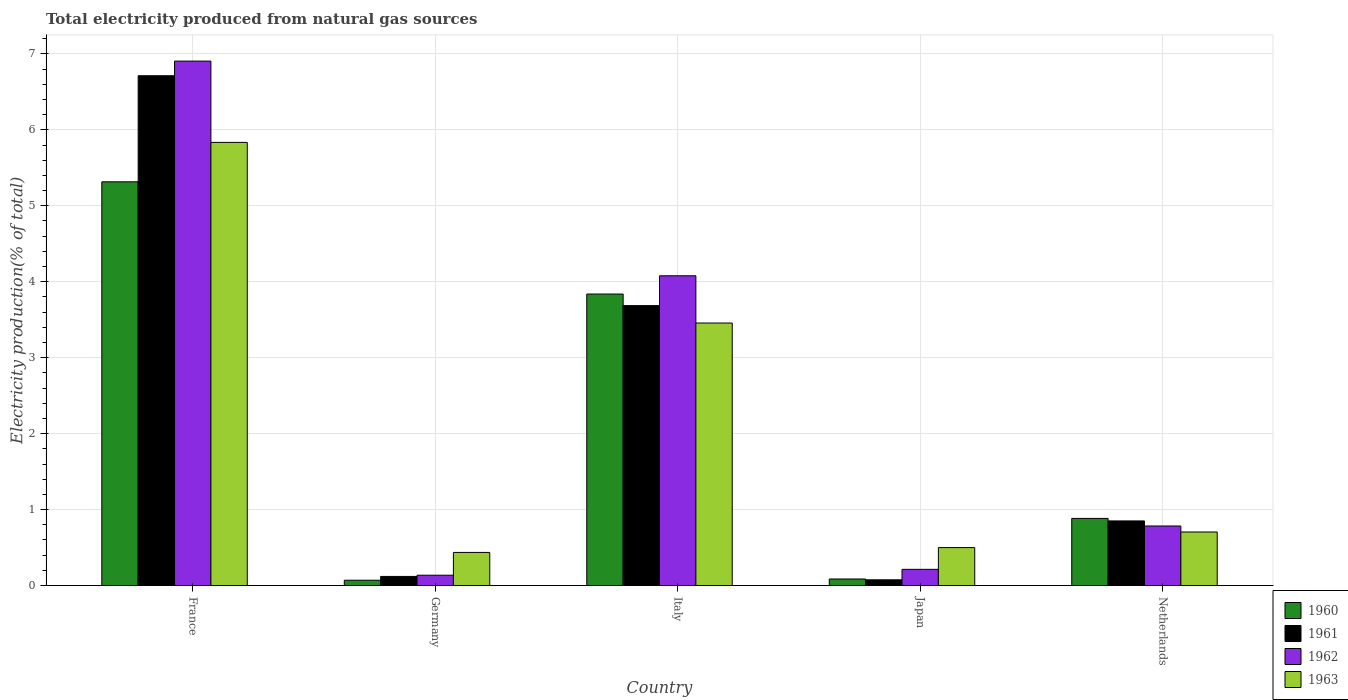How many different coloured bars are there?
Make the answer very short. 4. Are the number of bars per tick equal to the number of legend labels?
Give a very brief answer. Yes. How many bars are there on the 2nd tick from the left?
Offer a terse response. 4. How many bars are there on the 5th tick from the right?
Give a very brief answer. 4. What is the label of the 5th group of bars from the left?
Make the answer very short. Netherlands. What is the total electricity produced in 1961 in Japan?
Your response must be concise. 0.08. Across all countries, what is the maximum total electricity produced in 1961?
Give a very brief answer. 6.71. Across all countries, what is the minimum total electricity produced in 1962?
Your answer should be compact. 0.14. In which country was the total electricity produced in 1961 maximum?
Ensure brevity in your answer.  France. In which country was the total electricity produced in 1963 minimum?
Your response must be concise. Germany. What is the total total electricity produced in 1960 in the graph?
Offer a very short reply. 10.19. What is the difference between the total electricity produced in 1963 in France and that in Japan?
Provide a short and direct response. 5.33. What is the difference between the total electricity produced in 1960 in Japan and the total electricity produced in 1961 in Italy?
Ensure brevity in your answer.  -3.6. What is the average total electricity produced in 1962 per country?
Offer a terse response. 2.42. What is the difference between the total electricity produced of/in 1963 and total electricity produced of/in 1961 in Netherlands?
Provide a short and direct response. -0.15. In how many countries, is the total electricity produced in 1962 greater than 2.8 %?
Offer a terse response. 2. What is the ratio of the total electricity produced in 1960 in Germany to that in Italy?
Your response must be concise. 0.02. Is the difference between the total electricity produced in 1963 in Italy and Japan greater than the difference between the total electricity produced in 1961 in Italy and Japan?
Your response must be concise. No. What is the difference between the highest and the second highest total electricity produced in 1962?
Provide a succinct answer. -3.29. What is the difference between the highest and the lowest total electricity produced in 1960?
Your answer should be very brief. 5.25. In how many countries, is the total electricity produced in 1960 greater than the average total electricity produced in 1960 taken over all countries?
Provide a short and direct response. 2. What does the 3rd bar from the right in Germany represents?
Keep it short and to the point. 1961. How many bars are there?
Offer a very short reply. 20. Are all the bars in the graph horizontal?
Provide a short and direct response. No. How many countries are there in the graph?
Keep it short and to the point. 5. What is the difference between two consecutive major ticks on the Y-axis?
Keep it short and to the point. 1. Does the graph contain any zero values?
Your response must be concise. No. Does the graph contain grids?
Provide a succinct answer. Yes. Where does the legend appear in the graph?
Your answer should be compact. Bottom right. How are the legend labels stacked?
Ensure brevity in your answer.  Vertical. What is the title of the graph?
Ensure brevity in your answer.  Total electricity produced from natural gas sources. Does "1964" appear as one of the legend labels in the graph?
Offer a terse response. No. What is the label or title of the Y-axis?
Offer a terse response. Electricity production(% of total). What is the Electricity production(% of total) in 1960 in France?
Provide a short and direct response. 5.32. What is the Electricity production(% of total) of 1961 in France?
Make the answer very short. 6.71. What is the Electricity production(% of total) in 1962 in France?
Ensure brevity in your answer.  6.91. What is the Electricity production(% of total) of 1963 in France?
Provide a short and direct response. 5.83. What is the Electricity production(% of total) in 1960 in Germany?
Your response must be concise. 0.07. What is the Electricity production(% of total) in 1961 in Germany?
Your answer should be very brief. 0.12. What is the Electricity production(% of total) in 1962 in Germany?
Make the answer very short. 0.14. What is the Electricity production(% of total) in 1963 in Germany?
Offer a terse response. 0.44. What is the Electricity production(% of total) in 1960 in Italy?
Ensure brevity in your answer.  3.84. What is the Electricity production(% of total) in 1961 in Italy?
Your answer should be very brief. 3.69. What is the Electricity production(% of total) of 1962 in Italy?
Make the answer very short. 4.08. What is the Electricity production(% of total) of 1963 in Italy?
Ensure brevity in your answer.  3.46. What is the Electricity production(% of total) of 1960 in Japan?
Provide a short and direct response. 0.09. What is the Electricity production(% of total) in 1961 in Japan?
Provide a short and direct response. 0.08. What is the Electricity production(% of total) in 1962 in Japan?
Offer a very short reply. 0.21. What is the Electricity production(% of total) in 1963 in Japan?
Your response must be concise. 0.5. What is the Electricity production(% of total) of 1960 in Netherlands?
Provide a succinct answer. 0.88. What is the Electricity production(% of total) in 1961 in Netherlands?
Offer a very short reply. 0.85. What is the Electricity production(% of total) in 1962 in Netherlands?
Keep it short and to the point. 0.78. What is the Electricity production(% of total) in 1963 in Netherlands?
Offer a very short reply. 0.71. Across all countries, what is the maximum Electricity production(% of total) in 1960?
Make the answer very short. 5.32. Across all countries, what is the maximum Electricity production(% of total) in 1961?
Offer a very short reply. 6.71. Across all countries, what is the maximum Electricity production(% of total) in 1962?
Your response must be concise. 6.91. Across all countries, what is the maximum Electricity production(% of total) in 1963?
Make the answer very short. 5.83. Across all countries, what is the minimum Electricity production(% of total) in 1960?
Give a very brief answer. 0.07. Across all countries, what is the minimum Electricity production(% of total) of 1961?
Offer a very short reply. 0.08. Across all countries, what is the minimum Electricity production(% of total) of 1962?
Make the answer very short. 0.14. Across all countries, what is the minimum Electricity production(% of total) in 1963?
Keep it short and to the point. 0.44. What is the total Electricity production(% of total) of 1960 in the graph?
Offer a very short reply. 10.19. What is the total Electricity production(% of total) in 1961 in the graph?
Offer a terse response. 11.45. What is the total Electricity production(% of total) of 1962 in the graph?
Ensure brevity in your answer.  12.12. What is the total Electricity production(% of total) in 1963 in the graph?
Your response must be concise. 10.93. What is the difference between the Electricity production(% of total) in 1960 in France and that in Germany?
Keep it short and to the point. 5.25. What is the difference between the Electricity production(% of total) in 1961 in France and that in Germany?
Offer a terse response. 6.59. What is the difference between the Electricity production(% of total) in 1962 in France and that in Germany?
Offer a very short reply. 6.77. What is the difference between the Electricity production(% of total) of 1963 in France and that in Germany?
Your answer should be very brief. 5.4. What is the difference between the Electricity production(% of total) in 1960 in France and that in Italy?
Your answer should be very brief. 1.48. What is the difference between the Electricity production(% of total) of 1961 in France and that in Italy?
Make the answer very short. 3.03. What is the difference between the Electricity production(% of total) of 1962 in France and that in Italy?
Your answer should be compact. 2.83. What is the difference between the Electricity production(% of total) of 1963 in France and that in Italy?
Offer a very short reply. 2.38. What is the difference between the Electricity production(% of total) of 1960 in France and that in Japan?
Ensure brevity in your answer.  5.23. What is the difference between the Electricity production(% of total) of 1961 in France and that in Japan?
Your answer should be compact. 6.64. What is the difference between the Electricity production(% of total) in 1962 in France and that in Japan?
Provide a short and direct response. 6.69. What is the difference between the Electricity production(% of total) of 1963 in France and that in Japan?
Your answer should be compact. 5.33. What is the difference between the Electricity production(% of total) of 1960 in France and that in Netherlands?
Make the answer very short. 4.43. What is the difference between the Electricity production(% of total) in 1961 in France and that in Netherlands?
Give a very brief answer. 5.86. What is the difference between the Electricity production(% of total) of 1962 in France and that in Netherlands?
Keep it short and to the point. 6.12. What is the difference between the Electricity production(% of total) in 1963 in France and that in Netherlands?
Offer a very short reply. 5.13. What is the difference between the Electricity production(% of total) in 1960 in Germany and that in Italy?
Make the answer very short. -3.77. What is the difference between the Electricity production(% of total) in 1961 in Germany and that in Italy?
Give a very brief answer. -3.57. What is the difference between the Electricity production(% of total) of 1962 in Germany and that in Italy?
Your answer should be compact. -3.94. What is the difference between the Electricity production(% of total) in 1963 in Germany and that in Italy?
Your answer should be compact. -3.02. What is the difference between the Electricity production(% of total) in 1960 in Germany and that in Japan?
Provide a short and direct response. -0.02. What is the difference between the Electricity production(% of total) in 1961 in Germany and that in Japan?
Keep it short and to the point. 0.04. What is the difference between the Electricity production(% of total) of 1962 in Germany and that in Japan?
Ensure brevity in your answer.  -0.08. What is the difference between the Electricity production(% of total) in 1963 in Germany and that in Japan?
Provide a short and direct response. -0.06. What is the difference between the Electricity production(% of total) in 1960 in Germany and that in Netherlands?
Ensure brevity in your answer.  -0.81. What is the difference between the Electricity production(% of total) of 1961 in Germany and that in Netherlands?
Offer a very short reply. -0.73. What is the difference between the Electricity production(% of total) in 1962 in Germany and that in Netherlands?
Your response must be concise. -0.65. What is the difference between the Electricity production(% of total) in 1963 in Germany and that in Netherlands?
Provide a succinct answer. -0.27. What is the difference between the Electricity production(% of total) in 1960 in Italy and that in Japan?
Make the answer very short. 3.75. What is the difference between the Electricity production(% of total) of 1961 in Italy and that in Japan?
Give a very brief answer. 3.61. What is the difference between the Electricity production(% of total) in 1962 in Italy and that in Japan?
Your response must be concise. 3.86. What is the difference between the Electricity production(% of total) in 1963 in Italy and that in Japan?
Offer a terse response. 2.96. What is the difference between the Electricity production(% of total) of 1960 in Italy and that in Netherlands?
Give a very brief answer. 2.95. What is the difference between the Electricity production(% of total) of 1961 in Italy and that in Netherlands?
Provide a succinct answer. 2.83. What is the difference between the Electricity production(% of total) in 1962 in Italy and that in Netherlands?
Your answer should be compact. 3.29. What is the difference between the Electricity production(% of total) in 1963 in Italy and that in Netherlands?
Ensure brevity in your answer.  2.75. What is the difference between the Electricity production(% of total) in 1960 in Japan and that in Netherlands?
Provide a short and direct response. -0.8. What is the difference between the Electricity production(% of total) of 1961 in Japan and that in Netherlands?
Ensure brevity in your answer.  -0.78. What is the difference between the Electricity production(% of total) of 1962 in Japan and that in Netherlands?
Give a very brief answer. -0.57. What is the difference between the Electricity production(% of total) in 1963 in Japan and that in Netherlands?
Offer a very short reply. -0.21. What is the difference between the Electricity production(% of total) in 1960 in France and the Electricity production(% of total) in 1961 in Germany?
Your answer should be very brief. 5.2. What is the difference between the Electricity production(% of total) in 1960 in France and the Electricity production(% of total) in 1962 in Germany?
Provide a short and direct response. 5.18. What is the difference between the Electricity production(% of total) of 1960 in France and the Electricity production(% of total) of 1963 in Germany?
Provide a short and direct response. 4.88. What is the difference between the Electricity production(% of total) in 1961 in France and the Electricity production(% of total) in 1962 in Germany?
Give a very brief answer. 6.58. What is the difference between the Electricity production(% of total) of 1961 in France and the Electricity production(% of total) of 1963 in Germany?
Your answer should be very brief. 6.28. What is the difference between the Electricity production(% of total) in 1962 in France and the Electricity production(% of total) in 1963 in Germany?
Your answer should be very brief. 6.47. What is the difference between the Electricity production(% of total) of 1960 in France and the Electricity production(% of total) of 1961 in Italy?
Your answer should be very brief. 1.63. What is the difference between the Electricity production(% of total) in 1960 in France and the Electricity production(% of total) in 1962 in Italy?
Provide a succinct answer. 1.24. What is the difference between the Electricity production(% of total) of 1960 in France and the Electricity production(% of total) of 1963 in Italy?
Provide a succinct answer. 1.86. What is the difference between the Electricity production(% of total) in 1961 in France and the Electricity production(% of total) in 1962 in Italy?
Keep it short and to the point. 2.63. What is the difference between the Electricity production(% of total) of 1961 in France and the Electricity production(% of total) of 1963 in Italy?
Your answer should be compact. 3.26. What is the difference between the Electricity production(% of total) in 1962 in France and the Electricity production(% of total) in 1963 in Italy?
Provide a short and direct response. 3.45. What is the difference between the Electricity production(% of total) in 1960 in France and the Electricity production(% of total) in 1961 in Japan?
Offer a very short reply. 5.24. What is the difference between the Electricity production(% of total) in 1960 in France and the Electricity production(% of total) in 1962 in Japan?
Your answer should be compact. 5.1. What is the difference between the Electricity production(% of total) of 1960 in France and the Electricity production(% of total) of 1963 in Japan?
Keep it short and to the point. 4.82. What is the difference between the Electricity production(% of total) of 1961 in France and the Electricity production(% of total) of 1962 in Japan?
Make the answer very short. 6.5. What is the difference between the Electricity production(% of total) of 1961 in France and the Electricity production(% of total) of 1963 in Japan?
Provide a short and direct response. 6.21. What is the difference between the Electricity production(% of total) of 1962 in France and the Electricity production(% of total) of 1963 in Japan?
Offer a terse response. 6.4. What is the difference between the Electricity production(% of total) in 1960 in France and the Electricity production(% of total) in 1961 in Netherlands?
Make the answer very short. 4.46. What is the difference between the Electricity production(% of total) of 1960 in France and the Electricity production(% of total) of 1962 in Netherlands?
Your answer should be very brief. 4.53. What is the difference between the Electricity production(% of total) of 1960 in France and the Electricity production(% of total) of 1963 in Netherlands?
Make the answer very short. 4.61. What is the difference between the Electricity production(% of total) in 1961 in France and the Electricity production(% of total) in 1962 in Netherlands?
Make the answer very short. 5.93. What is the difference between the Electricity production(% of total) in 1961 in France and the Electricity production(% of total) in 1963 in Netherlands?
Your answer should be very brief. 6.01. What is the difference between the Electricity production(% of total) in 1962 in France and the Electricity production(% of total) in 1963 in Netherlands?
Offer a terse response. 6.2. What is the difference between the Electricity production(% of total) in 1960 in Germany and the Electricity production(% of total) in 1961 in Italy?
Offer a terse response. -3.62. What is the difference between the Electricity production(% of total) in 1960 in Germany and the Electricity production(% of total) in 1962 in Italy?
Ensure brevity in your answer.  -4.01. What is the difference between the Electricity production(% of total) in 1960 in Germany and the Electricity production(% of total) in 1963 in Italy?
Provide a short and direct response. -3.39. What is the difference between the Electricity production(% of total) in 1961 in Germany and the Electricity production(% of total) in 1962 in Italy?
Provide a succinct answer. -3.96. What is the difference between the Electricity production(% of total) in 1961 in Germany and the Electricity production(% of total) in 1963 in Italy?
Offer a terse response. -3.34. What is the difference between the Electricity production(% of total) of 1962 in Germany and the Electricity production(% of total) of 1963 in Italy?
Provide a short and direct response. -3.32. What is the difference between the Electricity production(% of total) of 1960 in Germany and the Electricity production(% of total) of 1961 in Japan?
Keep it short and to the point. -0.01. What is the difference between the Electricity production(% of total) in 1960 in Germany and the Electricity production(% of total) in 1962 in Japan?
Give a very brief answer. -0.14. What is the difference between the Electricity production(% of total) of 1960 in Germany and the Electricity production(% of total) of 1963 in Japan?
Provide a succinct answer. -0.43. What is the difference between the Electricity production(% of total) in 1961 in Germany and the Electricity production(% of total) in 1962 in Japan?
Your answer should be very brief. -0.09. What is the difference between the Electricity production(% of total) in 1961 in Germany and the Electricity production(% of total) in 1963 in Japan?
Provide a succinct answer. -0.38. What is the difference between the Electricity production(% of total) in 1962 in Germany and the Electricity production(% of total) in 1963 in Japan?
Your answer should be very brief. -0.36. What is the difference between the Electricity production(% of total) of 1960 in Germany and the Electricity production(% of total) of 1961 in Netherlands?
Provide a short and direct response. -0.78. What is the difference between the Electricity production(% of total) in 1960 in Germany and the Electricity production(% of total) in 1962 in Netherlands?
Make the answer very short. -0.71. What is the difference between the Electricity production(% of total) in 1960 in Germany and the Electricity production(% of total) in 1963 in Netherlands?
Give a very brief answer. -0.64. What is the difference between the Electricity production(% of total) of 1961 in Germany and the Electricity production(% of total) of 1962 in Netherlands?
Ensure brevity in your answer.  -0.66. What is the difference between the Electricity production(% of total) in 1961 in Germany and the Electricity production(% of total) in 1963 in Netherlands?
Give a very brief answer. -0.58. What is the difference between the Electricity production(% of total) of 1962 in Germany and the Electricity production(% of total) of 1963 in Netherlands?
Keep it short and to the point. -0.57. What is the difference between the Electricity production(% of total) of 1960 in Italy and the Electricity production(% of total) of 1961 in Japan?
Provide a short and direct response. 3.76. What is the difference between the Electricity production(% of total) in 1960 in Italy and the Electricity production(% of total) in 1962 in Japan?
Your answer should be compact. 3.62. What is the difference between the Electricity production(% of total) in 1960 in Italy and the Electricity production(% of total) in 1963 in Japan?
Offer a terse response. 3.34. What is the difference between the Electricity production(% of total) of 1961 in Italy and the Electricity production(% of total) of 1962 in Japan?
Keep it short and to the point. 3.47. What is the difference between the Electricity production(% of total) of 1961 in Italy and the Electricity production(% of total) of 1963 in Japan?
Provide a short and direct response. 3.19. What is the difference between the Electricity production(% of total) in 1962 in Italy and the Electricity production(% of total) in 1963 in Japan?
Your answer should be very brief. 3.58. What is the difference between the Electricity production(% of total) in 1960 in Italy and the Electricity production(% of total) in 1961 in Netherlands?
Your answer should be very brief. 2.99. What is the difference between the Electricity production(% of total) of 1960 in Italy and the Electricity production(% of total) of 1962 in Netherlands?
Your answer should be very brief. 3.05. What is the difference between the Electricity production(% of total) in 1960 in Italy and the Electricity production(% of total) in 1963 in Netherlands?
Provide a succinct answer. 3.13. What is the difference between the Electricity production(% of total) in 1961 in Italy and the Electricity production(% of total) in 1962 in Netherlands?
Offer a terse response. 2.9. What is the difference between the Electricity production(% of total) of 1961 in Italy and the Electricity production(% of total) of 1963 in Netherlands?
Offer a very short reply. 2.98. What is the difference between the Electricity production(% of total) in 1962 in Italy and the Electricity production(% of total) in 1963 in Netherlands?
Your response must be concise. 3.37. What is the difference between the Electricity production(% of total) of 1960 in Japan and the Electricity production(% of total) of 1961 in Netherlands?
Ensure brevity in your answer.  -0.76. What is the difference between the Electricity production(% of total) of 1960 in Japan and the Electricity production(% of total) of 1962 in Netherlands?
Ensure brevity in your answer.  -0.7. What is the difference between the Electricity production(% of total) in 1960 in Japan and the Electricity production(% of total) in 1963 in Netherlands?
Your answer should be very brief. -0.62. What is the difference between the Electricity production(% of total) in 1961 in Japan and the Electricity production(% of total) in 1962 in Netherlands?
Ensure brevity in your answer.  -0.71. What is the difference between the Electricity production(% of total) in 1961 in Japan and the Electricity production(% of total) in 1963 in Netherlands?
Your answer should be compact. -0.63. What is the difference between the Electricity production(% of total) of 1962 in Japan and the Electricity production(% of total) of 1963 in Netherlands?
Make the answer very short. -0.49. What is the average Electricity production(% of total) of 1960 per country?
Offer a very short reply. 2.04. What is the average Electricity production(% of total) in 1961 per country?
Give a very brief answer. 2.29. What is the average Electricity production(% of total) in 1962 per country?
Your answer should be compact. 2.42. What is the average Electricity production(% of total) in 1963 per country?
Offer a terse response. 2.19. What is the difference between the Electricity production(% of total) in 1960 and Electricity production(% of total) in 1961 in France?
Your response must be concise. -1.4. What is the difference between the Electricity production(% of total) in 1960 and Electricity production(% of total) in 1962 in France?
Offer a very short reply. -1.59. What is the difference between the Electricity production(% of total) in 1960 and Electricity production(% of total) in 1963 in France?
Provide a short and direct response. -0.52. What is the difference between the Electricity production(% of total) in 1961 and Electricity production(% of total) in 1962 in France?
Offer a very short reply. -0.19. What is the difference between the Electricity production(% of total) of 1961 and Electricity production(% of total) of 1963 in France?
Your answer should be very brief. 0.88. What is the difference between the Electricity production(% of total) of 1962 and Electricity production(% of total) of 1963 in France?
Provide a short and direct response. 1.07. What is the difference between the Electricity production(% of total) of 1960 and Electricity production(% of total) of 1962 in Germany?
Offer a very short reply. -0.07. What is the difference between the Electricity production(% of total) in 1960 and Electricity production(% of total) in 1963 in Germany?
Keep it short and to the point. -0.37. What is the difference between the Electricity production(% of total) of 1961 and Electricity production(% of total) of 1962 in Germany?
Make the answer very short. -0.02. What is the difference between the Electricity production(% of total) of 1961 and Electricity production(% of total) of 1963 in Germany?
Provide a short and direct response. -0.32. What is the difference between the Electricity production(% of total) of 1962 and Electricity production(% of total) of 1963 in Germany?
Offer a very short reply. -0.3. What is the difference between the Electricity production(% of total) in 1960 and Electricity production(% of total) in 1961 in Italy?
Make the answer very short. 0.15. What is the difference between the Electricity production(% of total) in 1960 and Electricity production(% of total) in 1962 in Italy?
Provide a succinct answer. -0.24. What is the difference between the Electricity production(% of total) of 1960 and Electricity production(% of total) of 1963 in Italy?
Offer a terse response. 0.38. What is the difference between the Electricity production(% of total) of 1961 and Electricity production(% of total) of 1962 in Italy?
Your answer should be compact. -0.39. What is the difference between the Electricity production(% of total) in 1961 and Electricity production(% of total) in 1963 in Italy?
Offer a very short reply. 0.23. What is the difference between the Electricity production(% of total) of 1962 and Electricity production(% of total) of 1963 in Italy?
Offer a very short reply. 0.62. What is the difference between the Electricity production(% of total) of 1960 and Electricity production(% of total) of 1961 in Japan?
Offer a very short reply. 0.01. What is the difference between the Electricity production(% of total) in 1960 and Electricity production(% of total) in 1962 in Japan?
Keep it short and to the point. -0.13. What is the difference between the Electricity production(% of total) of 1960 and Electricity production(% of total) of 1963 in Japan?
Keep it short and to the point. -0.41. What is the difference between the Electricity production(% of total) of 1961 and Electricity production(% of total) of 1962 in Japan?
Provide a short and direct response. -0.14. What is the difference between the Electricity production(% of total) of 1961 and Electricity production(% of total) of 1963 in Japan?
Give a very brief answer. -0.42. What is the difference between the Electricity production(% of total) of 1962 and Electricity production(% of total) of 1963 in Japan?
Your response must be concise. -0.29. What is the difference between the Electricity production(% of total) of 1960 and Electricity production(% of total) of 1961 in Netherlands?
Provide a short and direct response. 0.03. What is the difference between the Electricity production(% of total) of 1960 and Electricity production(% of total) of 1962 in Netherlands?
Offer a terse response. 0.1. What is the difference between the Electricity production(% of total) of 1960 and Electricity production(% of total) of 1963 in Netherlands?
Your answer should be compact. 0.18. What is the difference between the Electricity production(% of total) in 1961 and Electricity production(% of total) in 1962 in Netherlands?
Your answer should be very brief. 0.07. What is the difference between the Electricity production(% of total) of 1961 and Electricity production(% of total) of 1963 in Netherlands?
Give a very brief answer. 0.15. What is the difference between the Electricity production(% of total) of 1962 and Electricity production(% of total) of 1963 in Netherlands?
Provide a succinct answer. 0.08. What is the ratio of the Electricity production(% of total) of 1960 in France to that in Germany?
Your response must be concise. 75.62. What is the ratio of the Electricity production(% of total) in 1961 in France to that in Germany?
Offer a very short reply. 55.79. What is the ratio of the Electricity production(% of total) of 1962 in France to that in Germany?
Your answer should be compact. 50.69. What is the ratio of the Electricity production(% of total) in 1963 in France to that in Germany?
Your answer should be compact. 13.38. What is the ratio of the Electricity production(% of total) in 1960 in France to that in Italy?
Make the answer very short. 1.39. What is the ratio of the Electricity production(% of total) in 1961 in France to that in Italy?
Provide a short and direct response. 1.82. What is the ratio of the Electricity production(% of total) in 1962 in France to that in Italy?
Offer a very short reply. 1.69. What is the ratio of the Electricity production(% of total) of 1963 in France to that in Italy?
Give a very brief answer. 1.69. What is the ratio of the Electricity production(% of total) of 1960 in France to that in Japan?
Keep it short and to the point. 61.4. What is the ratio of the Electricity production(% of total) in 1961 in France to that in Japan?
Keep it short and to the point. 88.67. What is the ratio of the Electricity production(% of total) in 1962 in France to that in Japan?
Ensure brevity in your answer.  32.32. What is the ratio of the Electricity production(% of total) in 1963 in France to that in Japan?
Give a very brief answer. 11.67. What is the ratio of the Electricity production(% of total) in 1960 in France to that in Netherlands?
Give a very brief answer. 6.01. What is the ratio of the Electricity production(% of total) of 1961 in France to that in Netherlands?
Your answer should be very brief. 7.89. What is the ratio of the Electricity production(% of total) of 1962 in France to that in Netherlands?
Make the answer very short. 8.8. What is the ratio of the Electricity production(% of total) of 1963 in France to that in Netherlands?
Give a very brief answer. 8.27. What is the ratio of the Electricity production(% of total) in 1960 in Germany to that in Italy?
Give a very brief answer. 0.02. What is the ratio of the Electricity production(% of total) of 1961 in Germany to that in Italy?
Your answer should be very brief. 0.03. What is the ratio of the Electricity production(% of total) in 1962 in Germany to that in Italy?
Give a very brief answer. 0.03. What is the ratio of the Electricity production(% of total) of 1963 in Germany to that in Italy?
Offer a terse response. 0.13. What is the ratio of the Electricity production(% of total) of 1960 in Germany to that in Japan?
Give a very brief answer. 0.81. What is the ratio of the Electricity production(% of total) in 1961 in Germany to that in Japan?
Your answer should be very brief. 1.59. What is the ratio of the Electricity production(% of total) in 1962 in Germany to that in Japan?
Give a very brief answer. 0.64. What is the ratio of the Electricity production(% of total) in 1963 in Germany to that in Japan?
Make the answer very short. 0.87. What is the ratio of the Electricity production(% of total) of 1960 in Germany to that in Netherlands?
Your answer should be compact. 0.08. What is the ratio of the Electricity production(% of total) in 1961 in Germany to that in Netherlands?
Provide a succinct answer. 0.14. What is the ratio of the Electricity production(% of total) in 1962 in Germany to that in Netherlands?
Make the answer very short. 0.17. What is the ratio of the Electricity production(% of total) of 1963 in Germany to that in Netherlands?
Your response must be concise. 0.62. What is the ratio of the Electricity production(% of total) of 1960 in Italy to that in Japan?
Ensure brevity in your answer.  44.33. What is the ratio of the Electricity production(% of total) in 1961 in Italy to that in Japan?
Offer a terse response. 48.69. What is the ratio of the Electricity production(% of total) of 1962 in Italy to that in Japan?
Your answer should be compact. 19.09. What is the ratio of the Electricity production(% of total) of 1963 in Italy to that in Japan?
Offer a very short reply. 6.91. What is the ratio of the Electricity production(% of total) of 1960 in Italy to that in Netherlands?
Offer a terse response. 4.34. What is the ratio of the Electricity production(% of total) of 1961 in Italy to that in Netherlands?
Your answer should be compact. 4.33. What is the ratio of the Electricity production(% of total) in 1962 in Italy to that in Netherlands?
Give a very brief answer. 5.2. What is the ratio of the Electricity production(% of total) of 1963 in Italy to that in Netherlands?
Ensure brevity in your answer.  4.9. What is the ratio of the Electricity production(% of total) in 1960 in Japan to that in Netherlands?
Ensure brevity in your answer.  0.1. What is the ratio of the Electricity production(% of total) in 1961 in Japan to that in Netherlands?
Your answer should be compact. 0.09. What is the ratio of the Electricity production(% of total) in 1962 in Japan to that in Netherlands?
Offer a very short reply. 0.27. What is the ratio of the Electricity production(% of total) of 1963 in Japan to that in Netherlands?
Offer a very short reply. 0.71. What is the difference between the highest and the second highest Electricity production(% of total) of 1960?
Your response must be concise. 1.48. What is the difference between the highest and the second highest Electricity production(% of total) in 1961?
Your answer should be compact. 3.03. What is the difference between the highest and the second highest Electricity production(% of total) in 1962?
Keep it short and to the point. 2.83. What is the difference between the highest and the second highest Electricity production(% of total) of 1963?
Offer a very short reply. 2.38. What is the difference between the highest and the lowest Electricity production(% of total) of 1960?
Your answer should be very brief. 5.25. What is the difference between the highest and the lowest Electricity production(% of total) in 1961?
Give a very brief answer. 6.64. What is the difference between the highest and the lowest Electricity production(% of total) of 1962?
Make the answer very short. 6.77. What is the difference between the highest and the lowest Electricity production(% of total) in 1963?
Your response must be concise. 5.4. 